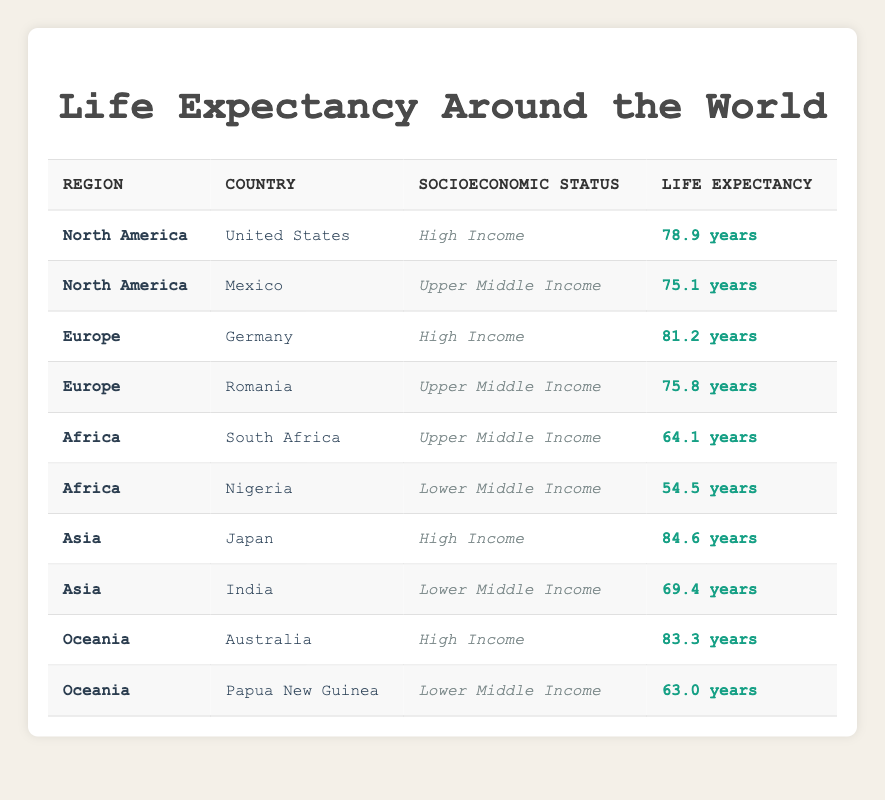What is the life expectancy in the United States? The table shows that the life expectancy for the United States, listed under North America and High-Income socioeconomic status, is 78.9 years.
Answer: 78.9 years What is the difference in life expectancy between Japan and Nigeria? Japan has a life expectancy of 84.6 years under High Income, while Nigeria has 54.5 years under Lower Middle Income. The difference is 84.6 - 54.5 = 30.1 years.
Answer: 30.1 years Is the life expectancy in Mexico higher than that in Romania? The table indicates that Mexico has a life expectancy of 75.1 years and Romania has 75.8 years. Since 75.1 is less than 75.8, this statement is false.
Answer: No Which region has the highest life expectancy recorded in the table? Looking through the regions, Japan in Asia has the highest life expectancy at 84.6 years, which is greater than the highest recorded for any other region in the table.
Answer: Asia What is the average life expectancy for Upper Middle Income countries in this table? The table lists two Upper Middle Income countries: Mexico (75.1 years) and Romania (75.8 years), South Africa (64.1 years). To find the average: (75.1 + 75.8 + 64.1) / 3 = 71.67 years.
Answer: 71.67 years Do Australia and Japan have the same life expectancy? Australia has a life expectancy of 83.3 years while Japan has 84.6 years, so they do not have the same life expectancy.
Answer: No Which country has the lowest life expectancy in the data? Among all the countries listed, Nigeria has the lowest life expectancy at 54.5 years, making it the country with the lowest expectancy in the data.
Answer: Nigeria Counting only High Income countries, what is the total life expectancy of these countries? There are two High Income countries: the United States (78.9 years) and Japan (84.6 years). The total is 78.9 + 84.6 = 163.5 years.
Answer: 163.5 years What socioeconomic status does Papua New Guinea hold in the data? The table states that Papua New Guinea is listed under the Lower Middle Income socioeconomic status.
Answer: Lower Middle Income 